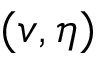<formula> <loc_0><loc_0><loc_500><loc_500>( v , \eta )</formula> 